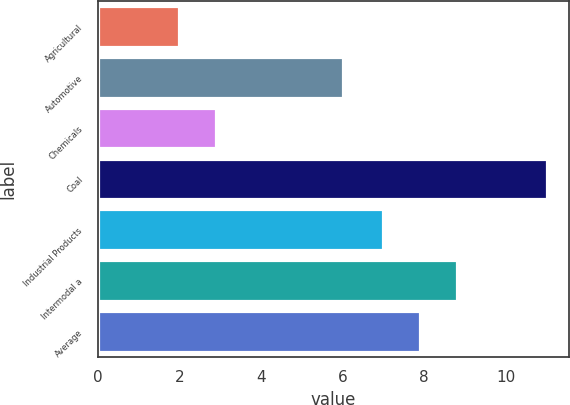Convert chart. <chart><loc_0><loc_0><loc_500><loc_500><bar_chart><fcel>Agricultural<fcel>Automotive<fcel>Chemicals<fcel>Coal<fcel>Industrial Products<fcel>Intermodal a<fcel>Average<nl><fcel>2<fcel>6<fcel>2.9<fcel>11<fcel>7<fcel>8.8<fcel>7.9<nl></chart> 